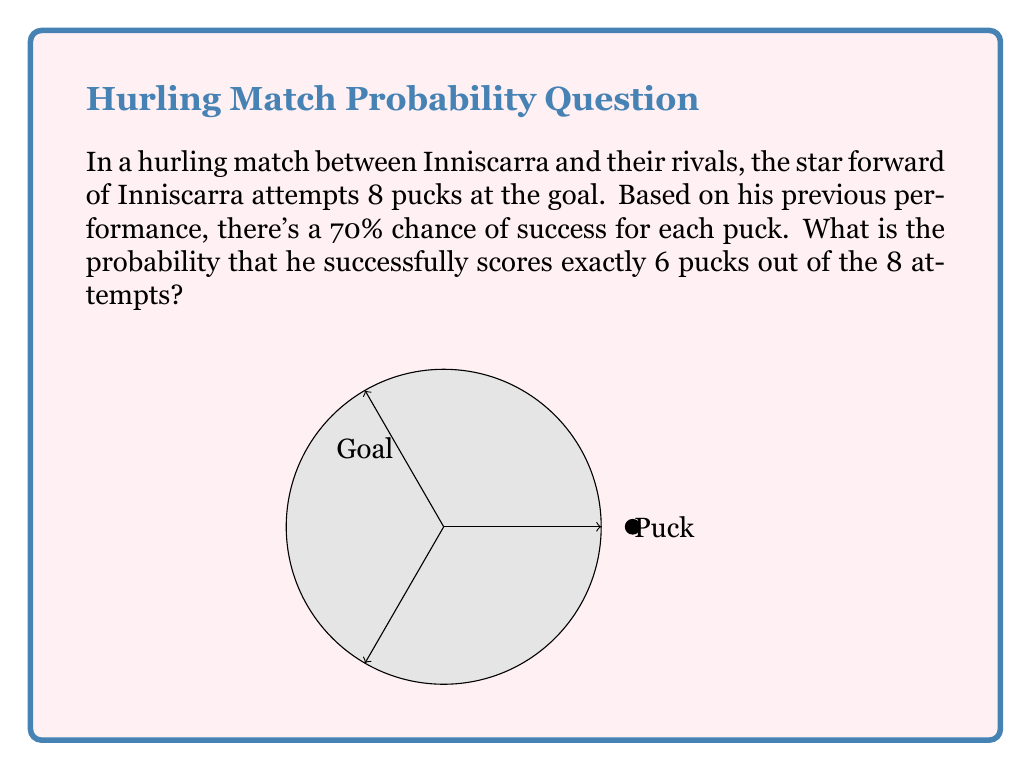Teach me how to tackle this problem. To solve this problem, we need to use the binomial distribution formula:

$$P(X=k) = \binom{n}{k} p^k (1-p)^{n-k}$$

Where:
- $n$ is the number of trials (8 pucks)
- $k$ is the number of successes (6 successful pucks)
- $p$ is the probability of success on each trial (70% or 0.7)

Step 1: Calculate the binomial coefficient $\binom{n}{k}$
$$\binom{8}{6} = \frac{8!}{6!(8-6)!} = \frac{8!}{6!2!} = 28$$

Step 2: Calculate $p^k$
$$0.7^6 \approx 0.1176$$

Step 3: Calculate $(1-p)^{n-k}$
$$(1-0.7)^{8-6} = 0.3^2 = 0.09$$

Step 4: Multiply all components
$$P(X=6) = 28 \times 0.1176 \times 0.09 \approx 0.2966$$

Therefore, the probability of scoring exactly 6 pucks out of 8 attempts is approximately 0.2966 or 29.66%.
Answer: $0.2966$ or $29.66\%$ 